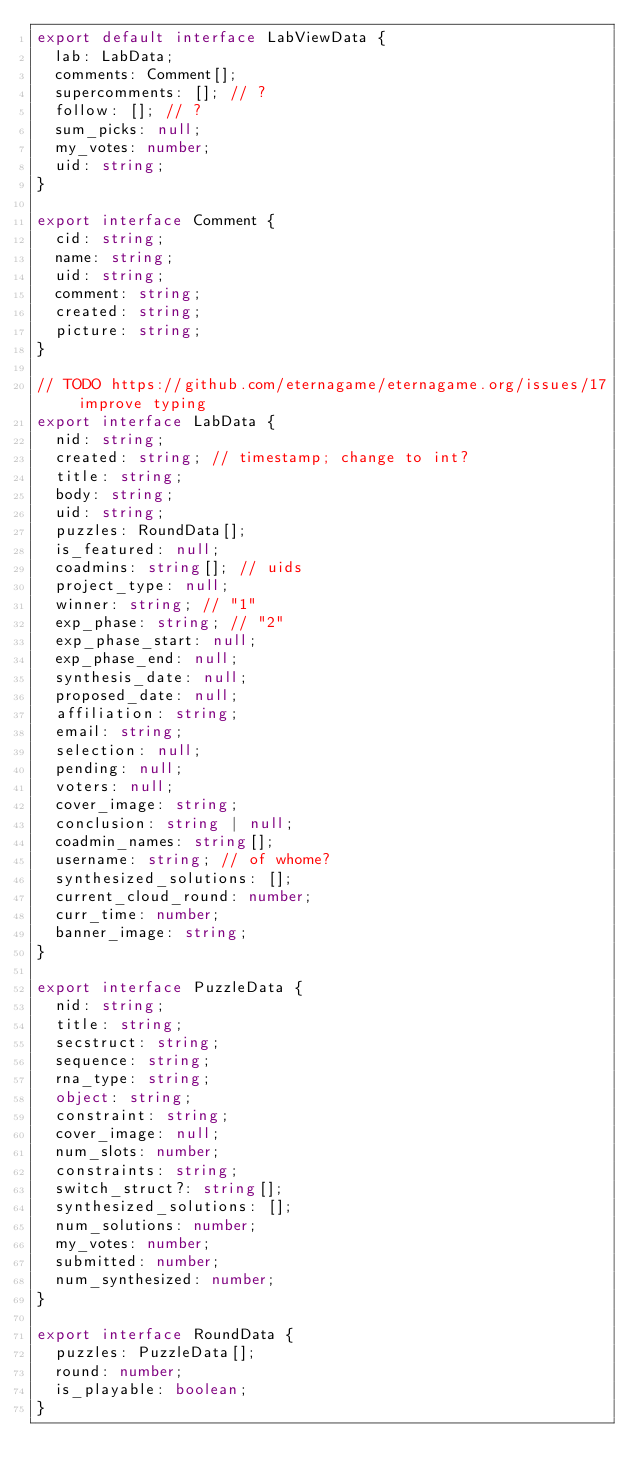<code> <loc_0><loc_0><loc_500><loc_500><_TypeScript_>export default interface LabViewData {
  lab: LabData;
  comments: Comment[];
  supercomments: []; // ?
  follow: []; // ?
  sum_picks: null;
  my_votes: number;
  uid: string;
}

export interface Comment {
  cid: string;
  name: string;
  uid: string;
  comment: string;
  created: string;
  picture: string;
}

// TODO https://github.com/eternagame/eternagame.org/issues/17 improve typing
export interface LabData {
  nid: string;
  created: string; // timestamp; change to int?
  title: string;
  body: string;
  uid: string;
  puzzles: RoundData[];
  is_featured: null;
  coadmins: string[]; // uids
  project_type: null;
  winner: string; // "1"
  exp_phase: string; // "2"
  exp_phase_start: null;
  exp_phase_end: null;
  synthesis_date: null;
  proposed_date: null;
  affiliation: string;
  email: string;
  selection: null;
  pending: null;
  voters: null;
  cover_image: string;
  conclusion: string | null;
  coadmin_names: string[];
  username: string; // of whome?
  synthesized_solutions: [];
  current_cloud_round: number;
  curr_time: number;
  banner_image: string;
}

export interface PuzzleData {
  nid: string;
  title: string;
  secstruct: string;
  sequence: string;
  rna_type: string;
  object: string;
  constraint: string;
  cover_image: null;
  num_slots: number;
  constraints: string;
  switch_struct?: string[];
  synthesized_solutions: [];
  num_solutions: number;
  my_votes: number;
  submitted: number;
  num_synthesized: number;
}

export interface RoundData {
  puzzles: PuzzleData[];
  round: number;
  is_playable: boolean;
}
</code> 